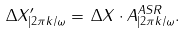<formula> <loc_0><loc_0><loc_500><loc_500>\Delta X ^ { \prime } _ { | 2 \pi k / \omega } = \, \Delta X \cdot A ^ { A S R } _ { | 2 \pi k / \omega } .</formula> 